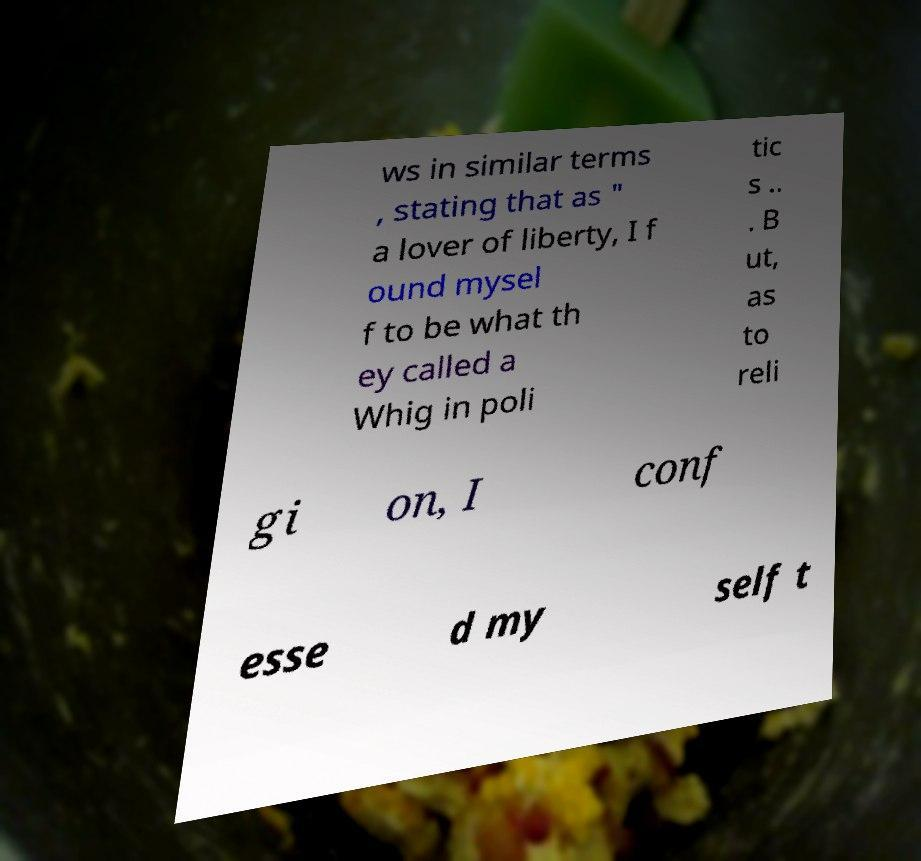Can you read and provide the text displayed in the image?This photo seems to have some interesting text. Can you extract and type it out for me? ws in similar terms , stating that as " a lover of liberty, I f ound mysel f to be what th ey called a Whig in poli tic s .. . B ut, as to reli gi on, I conf esse d my self t 